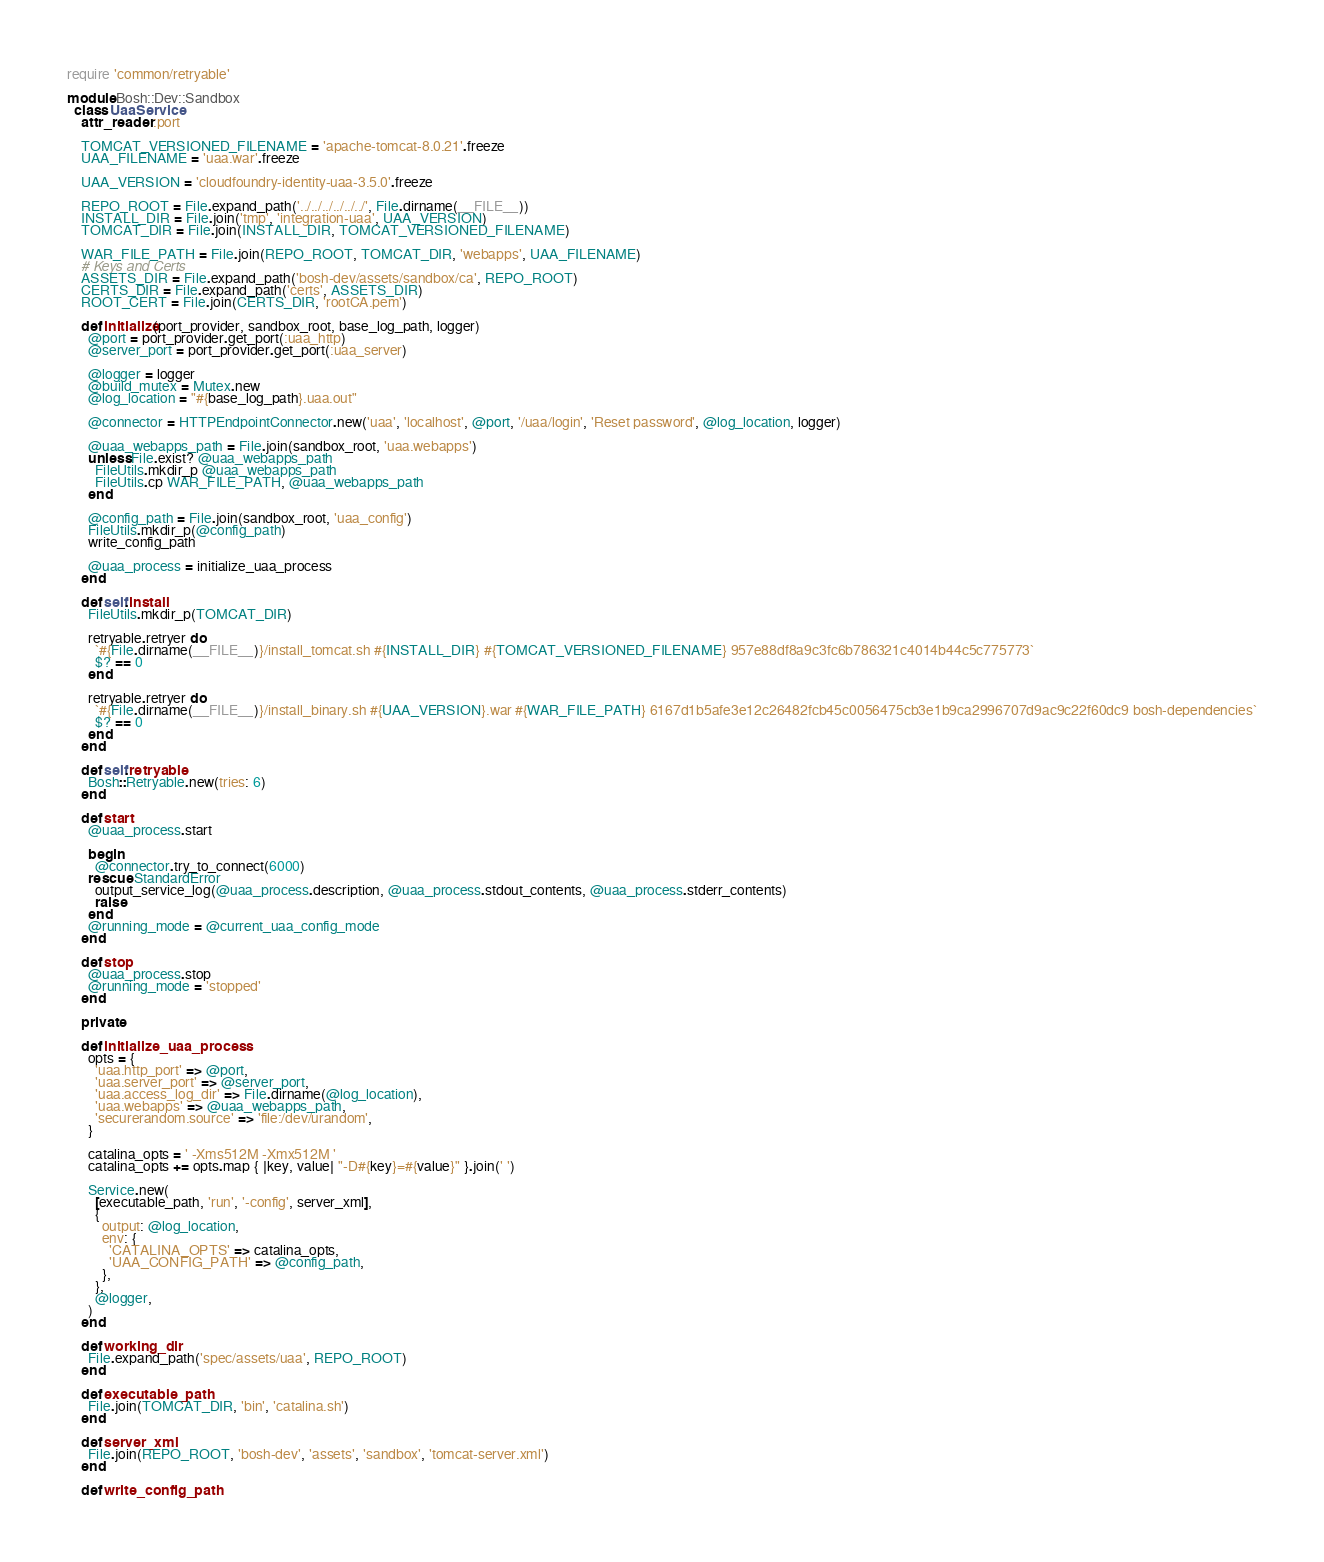<code> <loc_0><loc_0><loc_500><loc_500><_Ruby_>require 'common/retryable'

module Bosh::Dev::Sandbox
  class UaaService
    attr_reader :port

    TOMCAT_VERSIONED_FILENAME = 'apache-tomcat-8.0.21'.freeze
    UAA_FILENAME = 'uaa.war'.freeze

    UAA_VERSION = 'cloudfoundry-identity-uaa-3.5.0'.freeze

    REPO_ROOT = File.expand_path('../../../../../../', File.dirname(__FILE__))
    INSTALL_DIR = File.join('tmp', 'integration-uaa', UAA_VERSION)
    TOMCAT_DIR = File.join(INSTALL_DIR, TOMCAT_VERSIONED_FILENAME)

    WAR_FILE_PATH = File.join(REPO_ROOT, TOMCAT_DIR, 'webapps', UAA_FILENAME)
    # Keys and Certs
    ASSETS_DIR = File.expand_path('bosh-dev/assets/sandbox/ca', REPO_ROOT)
    CERTS_DIR = File.expand_path('certs', ASSETS_DIR)
    ROOT_CERT = File.join(CERTS_DIR, 'rootCA.pem')

    def initialize(port_provider, sandbox_root, base_log_path, logger)
      @port = port_provider.get_port(:uaa_http)
      @server_port = port_provider.get_port(:uaa_server)

      @logger = logger
      @build_mutex = Mutex.new
      @log_location = "#{base_log_path}.uaa.out"

      @connector = HTTPEndpointConnector.new('uaa', 'localhost', @port, '/uaa/login', 'Reset password', @log_location, logger)

      @uaa_webapps_path = File.join(sandbox_root, 'uaa.webapps')
      unless File.exist? @uaa_webapps_path
        FileUtils.mkdir_p @uaa_webapps_path
        FileUtils.cp WAR_FILE_PATH, @uaa_webapps_path
      end

      @config_path = File.join(sandbox_root, 'uaa_config')
      FileUtils.mkdir_p(@config_path)
      write_config_path

      @uaa_process = initialize_uaa_process
    end

    def self.install
      FileUtils.mkdir_p(TOMCAT_DIR)

      retryable.retryer do
        `#{File.dirname(__FILE__)}/install_tomcat.sh #{INSTALL_DIR} #{TOMCAT_VERSIONED_FILENAME} 957e88df8a9c3fc6b786321c4014b44c5c775773`
        $? == 0
      end

      retryable.retryer do
        `#{File.dirname(__FILE__)}/install_binary.sh #{UAA_VERSION}.war #{WAR_FILE_PATH} 6167d1b5afe3e12c26482fcb45c0056475cb3e1b9ca2996707d9ac9c22f60dc9 bosh-dependencies`
        $? == 0
      end
    end

    def self.retryable
      Bosh::Retryable.new(tries: 6)
    end

    def start
      @uaa_process.start

      begin
        @connector.try_to_connect(6000)
      rescue StandardError
        output_service_log(@uaa_process.description, @uaa_process.stdout_contents, @uaa_process.stderr_contents)
        raise
      end
      @running_mode = @current_uaa_config_mode
    end

    def stop
      @uaa_process.stop
      @running_mode = 'stopped'
    end

    private

    def initialize_uaa_process
      opts = {
        'uaa.http_port' => @port,
        'uaa.server_port' => @server_port,
        'uaa.access_log_dir' => File.dirname(@log_location),
        'uaa.webapps' => @uaa_webapps_path,
        'securerandom.source' => 'file:/dev/urandom',
      }

      catalina_opts = ' -Xms512M -Xmx512M '
      catalina_opts += opts.map { |key, value| "-D#{key}=#{value}" }.join(' ')

      Service.new(
        [executable_path, 'run', '-config', server_xml],
        {
          output: @log_location,
          env: {
            'CATALINA_OPTS' => catalina_opts,
            'UAA_CONFIG_PATH' => @config_path,
          },
        },
        @logger,
      )
    end

    def working_dir
      File.expand_path('spec/assets/uaa', REPO_ROOT)
    end

    def executable_path
      File.join(TOMCAT_DIR, 'bin', 'catalina.sh')
    end

    def server_xml
      File.join(REPO_ROOT, 'bosh-dev', 'assets', 'sandbox', 'tomcat-server.xml')
    end

    def write_config_path</code> 